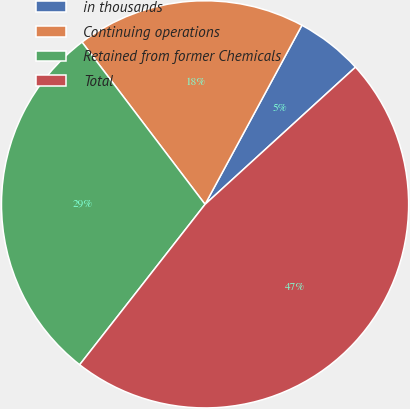<chart> <loc_0><loc_0><loc_500><loc_500><pie_chart><fcel>in thousands<fcel>Continuing operations<fcel>Retained from former Chemicals<fcel>Total<nl><fcel>5.34%<fcel>18.22%<fcel>29.11%<fcel>47.33%<nl></chart> 